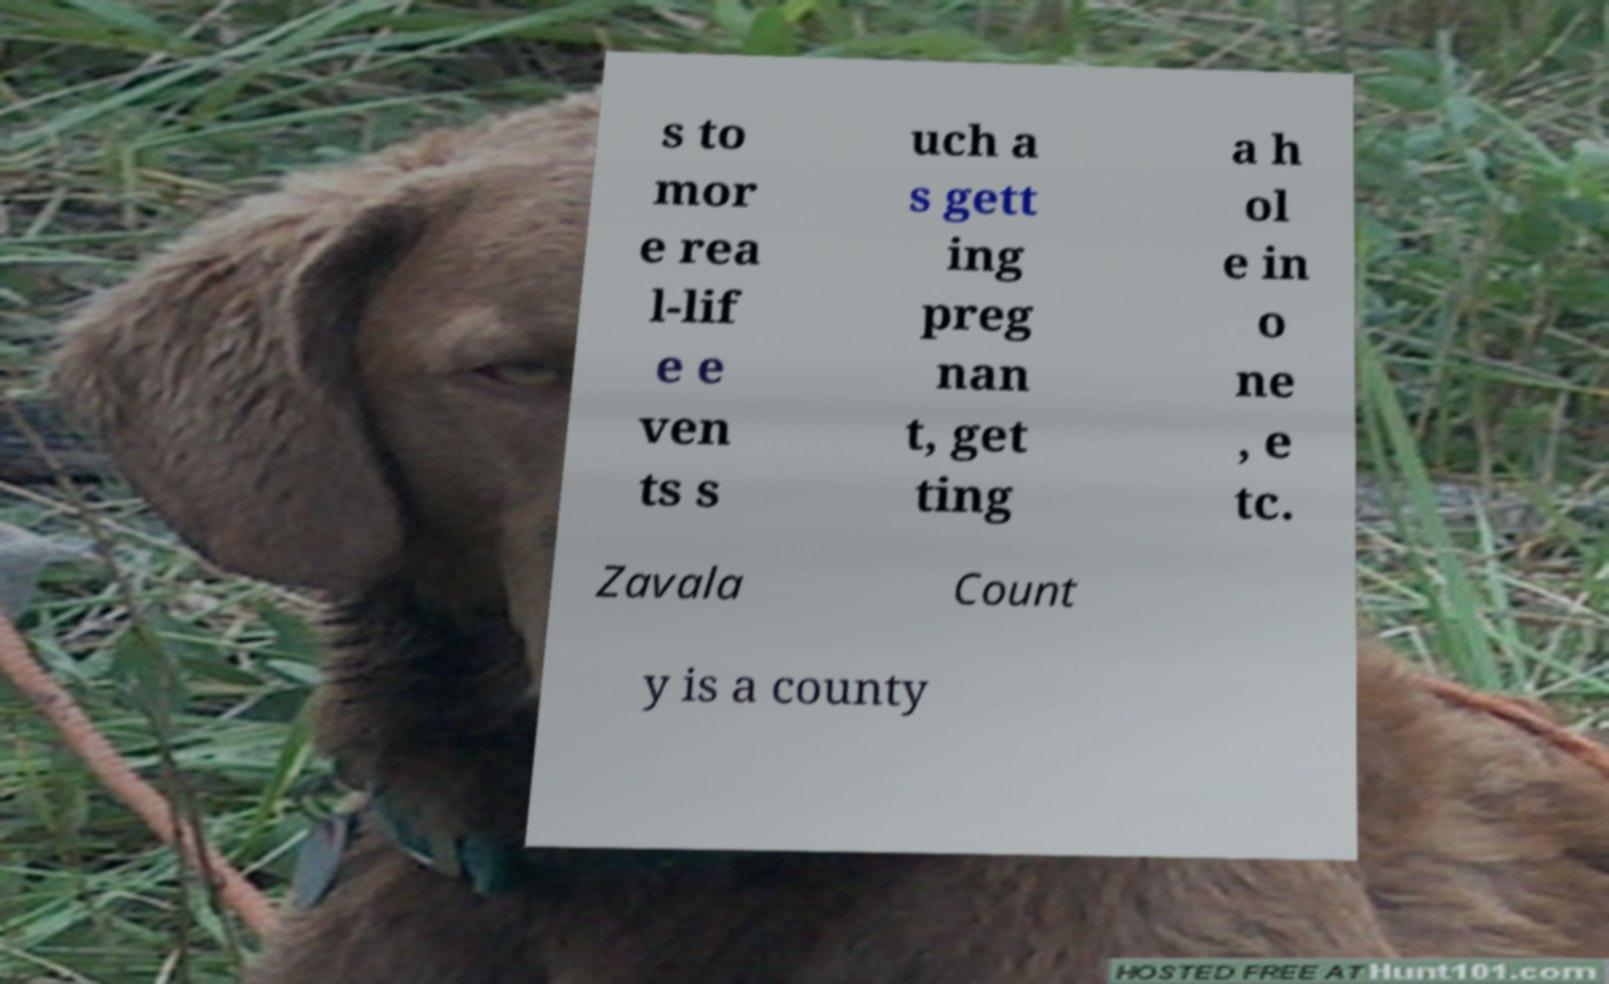Could you assist in decoding the text presented in this image and type it out clearly? s to mor e rea l-lif e e ven ts s uch a s gett ing preg nan t, get ting a h ol e in o ne , e tc. Zavala Count y is a county 